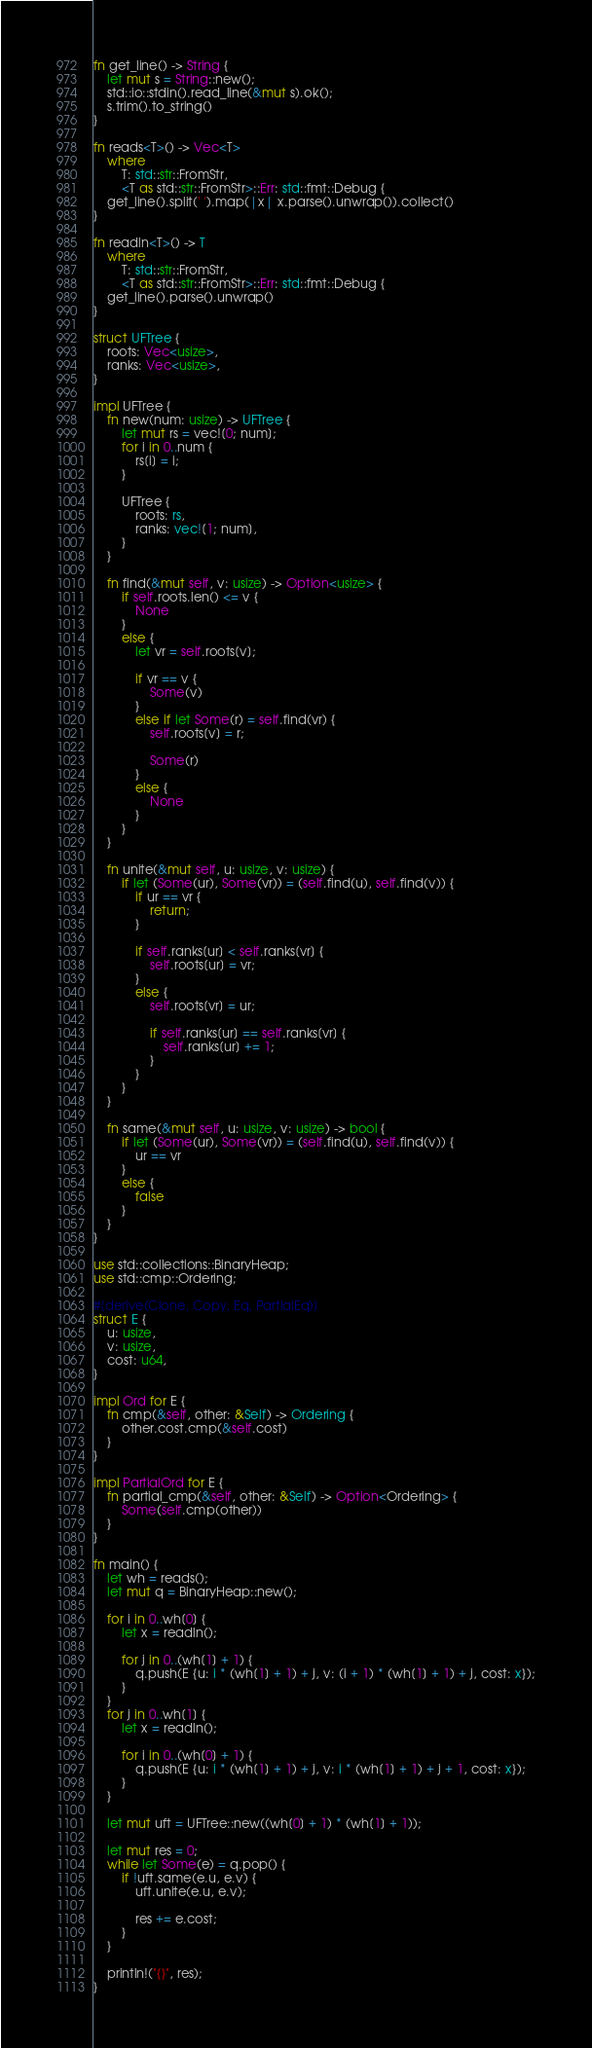<code> <loc_0><loc_0><loc_500><loc_500><_Rust_>fn get_line() -> String {
    let mut s = String::new();
    std::io::stdin().read_line(&mut s).ok();
    s.trim().to_string()
}

fn reads<T>() -> Vec<T>
    where
        T: std::str::FromStr,
        <T as std::str::FromStr>::Err: std::fmt::Debug {
    get_line().split(' ').map(|x| x.parse().unwrap()).collect()
}

fn readln<T>() -> T
    where
        T: std::str::FromStr,
        <T as std::str::FromStr>::Err: std::fmt::Debug {
    get_line().parse().unwrap()
}

struct UFTree {
    roots: Vec<usize>,
    ranks: Vec<usize>,
}

impl UFTree {
    fn new(num: usize) -> UFTree {
        let mut rs = vec![0; num];
        for i in 0..num {
            rs[i] = i;
        }

        UFTree {
            roots: rs,
            ranks: vec![1; num],
        }
    }

    fn find(&mut self, v: usize) -> Option<usize> {
        if self.roots.len() <= v {
            None
        }
        else {
            let vr = self.roots[v];

            if vr == v {
                Some(v)
            }
            else if let Some(r) = self.find(vr) {
                self.roots[v] = r;

                Some(r)
            }
            else {
                None
            }
        }
    }

    fn unite(&mut self, u: usize, v: usize) {
        if let (Some(ur), Some(vr)) = (self.find(u), self.find(v)) {
            if ur == vr {
                return;
            }

            if self.ranks[ur] < self.ranks[vr] {
                self.roots[ur] = vr;
            }
            else {
                self.roots[vr] = ur;

                if self.ranks[ur] == self.ranks[vr] {
                    self.ranks[ur] += 1;
                }
            }
        }
    }

    fn same(&mut self, u: usize, v: usize) -> bool {
        if let (Some(ur), Some(vr)) = (self.find(u), self.find(v)) {
            ur == vr
        }
        else {
            false
        }
    }
}

use std::collections::BinaryHeap;
use std::cmp::Ordering;

#[derive(Clone, Copy, Eq, PartialEq)]
struct E {
    u: usize,
    v: usize,
    cost: u64,
}

impl Ord for E {
    fn cmp(&self, other: &Self) -> Ordering {
        other.cost.cmp(&self.cost)
    }
}

impl PartialOrd for E {
    fn partial_cmp(&self, other: &Self) -> Option<Ordering> {
        Some(self.cmp(other))
    }
}

fn main() {
    let wh = reads();
    let mut q = BinaryHeap::new();

    for i in 0..wh[0] {
        let x = readln();

        for j in 0..(wh[1] + 1) {
            q.push(E {u: i * (wh[1] + 1) + j, v: (i + 1) * (wh[1] + 1) + j, cost: x});
        }
    }
    for j in 0..wh[1] {
        let x = readln();

        for i in 0..(wh[0] + 1) {
            q.push(E {u: i * (wh[1] + 1) + j, v: i * (wh[1] + 1) + j + 1, cost: x});
        }
    }

    let mut uft = UFTree::new((wh[0] + 1) * (wh[1] + 1));

    let mut res = 0;
    while let Some(e) = q.pop() {
        if !uft.same(e.u, e.v) {
            uft.unite(e.u, e.v);

            res += e.cost;
        }
    }

    println!("{}", res);
}
</code> 